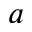<formula> <loc_0><loc_0><loc_500><loc_500>a</formula> 